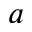<formula> <loc_0><loc_0><loc_500><loc_500>a</formula> 